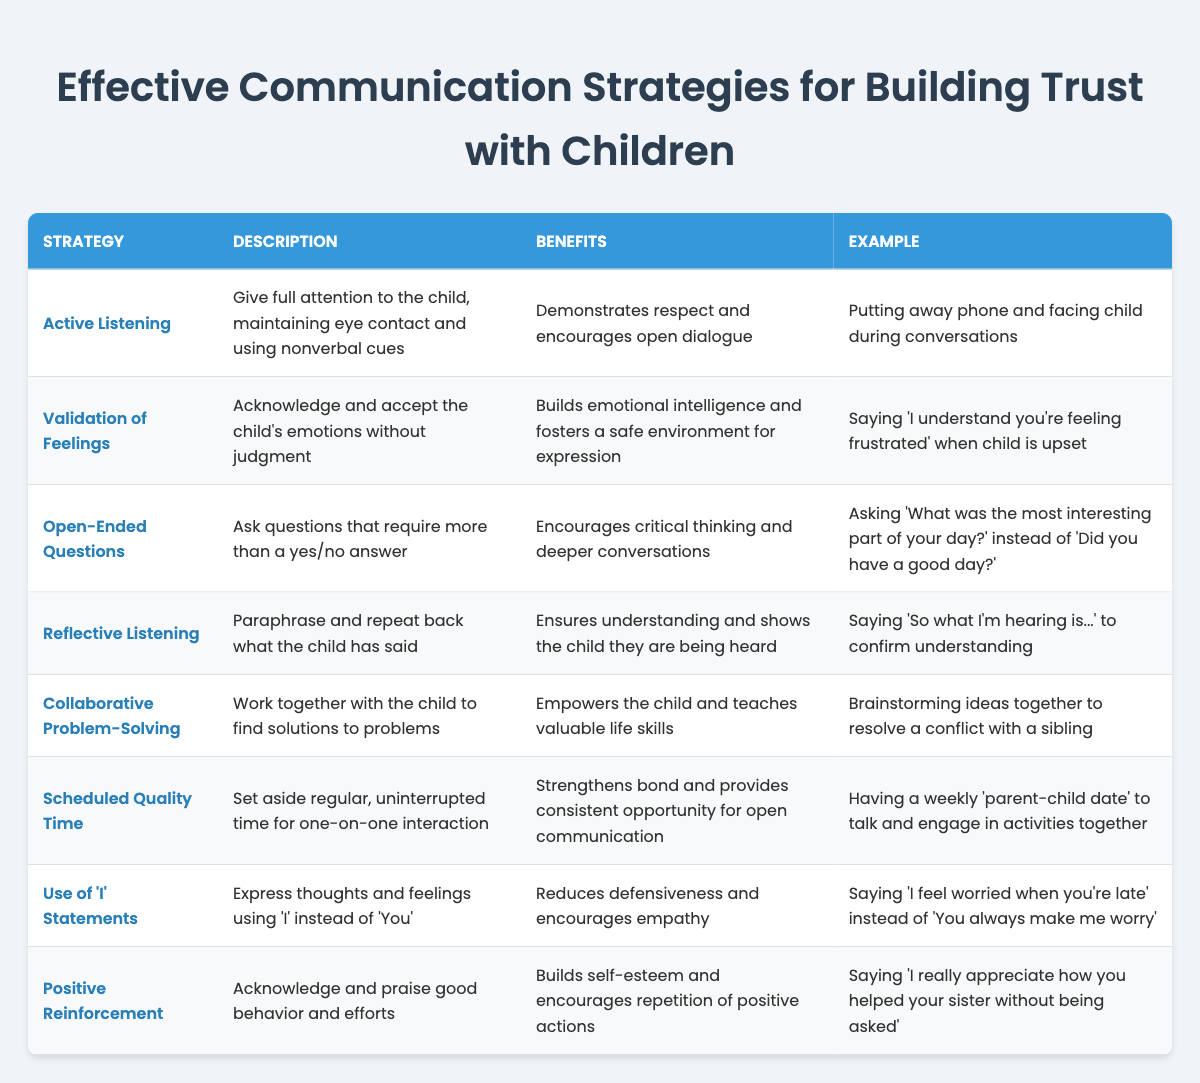What is one of the benefits of Active Listening? The table indicates that Active Listening demonstrates respect and encourages open dialogue, which is one of its benefits. This can be seen in the "Benefits" column associated with the "Active Listening" strategy.
Answer: Demonstrates respect and encourages open dialogue What example is provided for Reflective Listening? By looking at the "Example" column for Reflective Listening, we find that it says, "Saying 'So what I'm hearing is...' to confirm understanding." This confirms what is expected in this communication strategy.
Answer: Saying 'So what I'm hearing is...' to confirm understanding How many communication strategies listed on the table have a benefit related to emotional intelligence? The table indicates that two strategies—Validation of Feelings and Reflective Listening—highlight emotional intelligence in their benefits. Thus, by counting their occurrences, we ascertain the total.
Answer: 2 Is using 'I' statements considered a communication strategy in building trust with children? According to the table, "Use of 'I' Statements" is indeed listed as a communication strategy. Therefore, the answer is positive.
Answer: Yes Which strategy encourages deeper conversations through questioning? By reviewing the "Communication Strategies" section, we can see that "Open-Ended Questions" specifically encourages deeper conversations through the type of questions posed.
Answer: Open-Ended Questions What are the benefits of Scheduled Quality Time? The benefits of Scheduled Quality Time, based on the "Benefits" column, indicate that it strengthens bond and provides consistent opportunity for open communication. Thus, we can summarize these points.
Answer: Strengthens bond and provides consistent opportunity for open communication Which strategy is focused on collaborative efforts to solve problems? The table clearly identifies "Collaborative Problem-Solving" as the strategy that emphasizes working together with the child, evident from its description.
Answer: Collaborative Problem-Solving If we summarize the benefits listed in the table, how many unique benefits can be identified? By reviewing the benefits for each listed strategy, we identify six unique benefits: respecting dialogue, building emotional intelligence, encouraging critical thinking, confirming understanding, empowering children, and building self-esteem. This leads to the total number of distinct benefits.
Answer: 6 